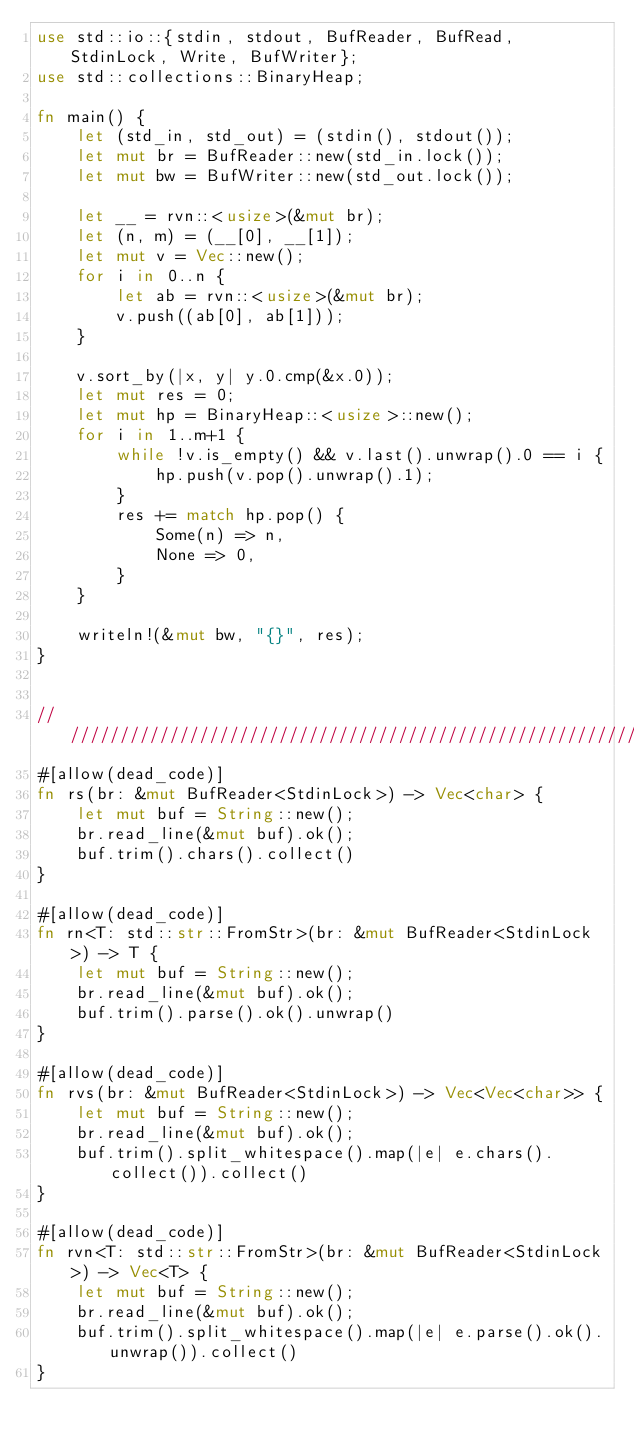Convert code to text. <code><loc_0><loc_0><loc_500><loc_500><_Rust_>use std::io::{stdin, stdout, BufReader, BufRead, StdinLock, Write, BufWriter};
use std::collections::BinaryHeap;

fn main() {
    let (std_in, std_out) = (stdin(), stdout());
    let mut br = BufReader::new(std_in.lock());
    let mut bw = BufWriter::new(std_out.lock());
    
    let __ = rvn::<usize>(&mut br);
    let (n, m) = (__[0], __[1]);
    let mut v = Vec::new();
    for i in 0..n {
        let ab = rvn::<usize>(&mut br);
        v.push((ab[0], ab[1]));
    }

    v.sort_by(|x, y| y.0.cmp(&x.0));
    let mut res = 0;
    let mut hp = BinaryHeap::<usize>::new();
    for i in 1..m+1 {
        while !v.is_empty() && v.last().unwrap().0 == i {
            hp.push(v.pop().unwrap().1);
        }
        res += match hp.pop() {
            Some(n) => n,
            None => 0,
        }
    }
    
    writeln!(&mut bw, "{}", res);
}


//////////////////////////////////////////////////////////////////////////////////
#[allow(dead_code)]
fn rs(br: &mut BufReader<StdinLock>) -> Vec<char> {
    let mut buf = String::new();
    br.read_line(&mut buf).ok();
    buf.trim().chars().collect()
}

#[allow(dead_code)]
fn rn<T: std::str::FromStr>(br: &mut BufReader<StdinLock>) -> T {
    let mut buf = String::new();
    br.read_line(&mut buf).ok();
    buf.trim().parse().ok().unwrap()
}

#[allow(dead_code)]
fn rvs(br: &mut BufReader<StdinLock>) -> Vec<Vec<char>> {
    let mut buf = String::new();
    br.read_line(&mut buf).ok();
    buf.trim().split_whitespace().map(|e| e.chars().collect()).collect()
}

#[allow(dead_code)]
fn rvn<T: std::str::FromStr>(br: &mut BufReader<StdinLock>) -> Vec<T> {
    let mut buf = String::new();
    br.read_line(&mut buf).ok();
    buf.trim().split_whitespace().map(|e| e.parse().ok().unwrap()).collect()
}</code> 